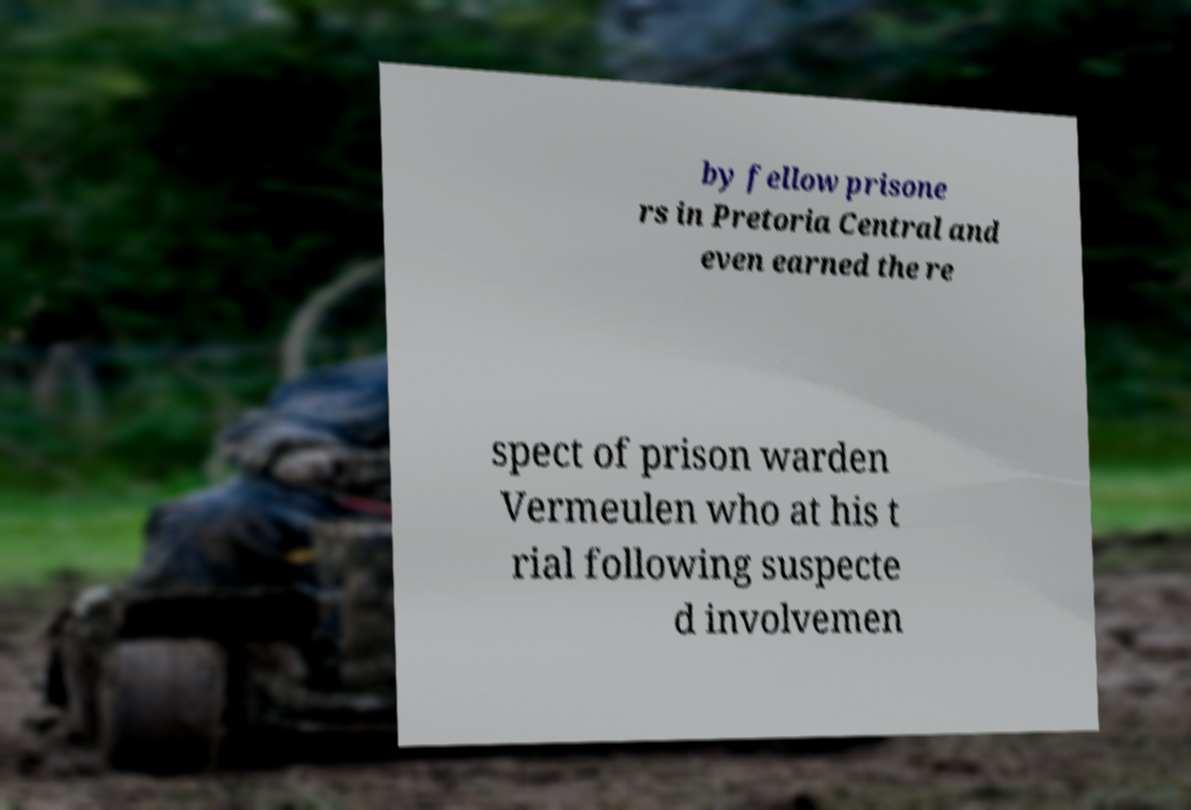Can you accurately transcribe the text from the provided image for me? by fellow prisone rs in Pretoria Central and even earned the re spect of prison warden Vermeulen who at his t rial following suspecte d involvemen 